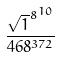<formula> <loc_0><loc_0><loc_500><loc_500>\frac { { \sqrt { 1 } ^ { 8 } } ^ { 1 0 } } { 4 6 8 ^ { 3 7 2 } }</formula> 